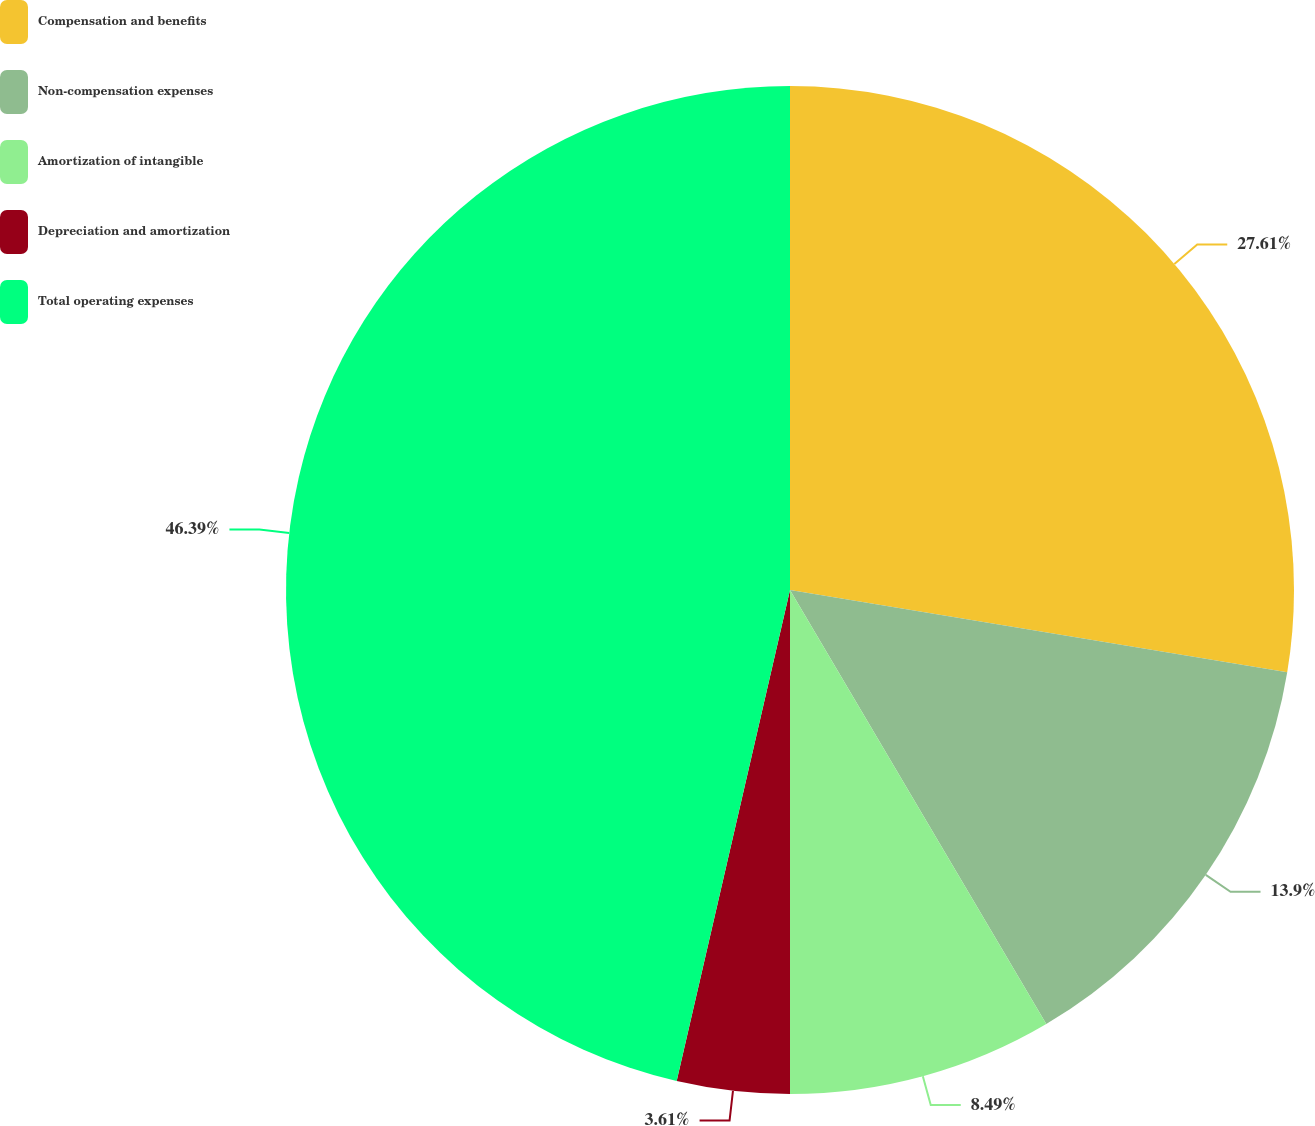Convert chart. <chart><loc_0><loc_0><loc_500><loc_500><pie_chart><fcel>Compensation and benefits<fcel>Non-compensation expenses<fcel>Amortization of intangible<fcel>Depreciation and amortization<fcel>Total operating expenses<nl><fcel>27.61%<fcel>13.9%<fcel>8.49%<fcel>3.61%<fcel>46.39%<nl></chart> 